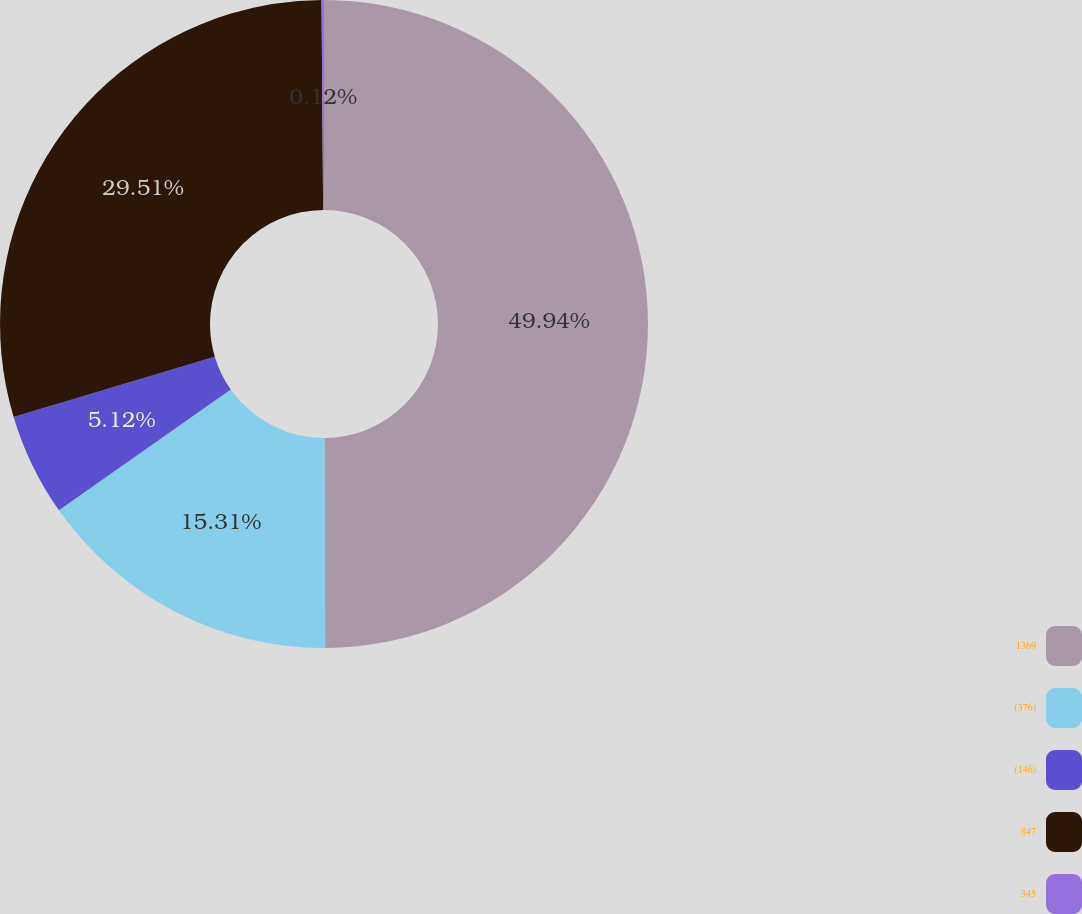Convert chart to OTSL. <chart><loc_0><loc_0><loc_500><loc_500><pie_chart><fcel>1369<fcel>(376)<fcel>(146)<fcel>847<fcel>345<nl><fcel>49.94%<fcel>15.31%<fcel>5.12%<fcel>29.51%<fcel>0.12%<nl></chart> 